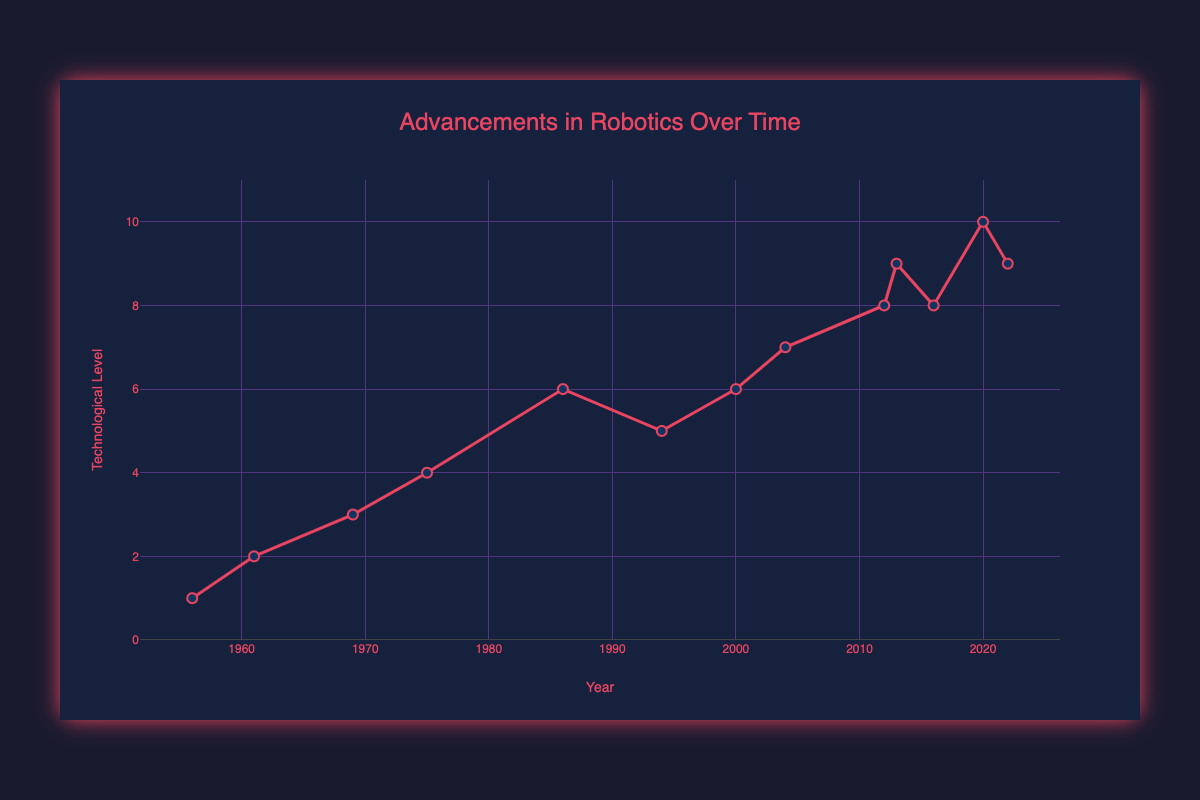Which year marked the first significant milestone in robotics, resulting in the technological level increasing from 1 to 2? The plot shows the technological level starting at 1 in 1956 and increasing to 2 in 1961. The milestone in 1961 was the deployment of the first industrial robot, Unimate, in a General Motors factory.
Answer: 1961 Between which two consecutive years did the technological level of robotics show the most significant increase? To find the most significant increase, observe the largest vertical distance between two consecutive points in the plot. The biggest jump in technological level is from 1975 (level 4) to 1986 (level 6), an increase of 2 levels.
Answer: 1975 and 1986 By how many levels did the technological level increase from 1961 to 1969? From 1961 (level 2) to 1969 (level 3), the technological level increased by subtracting 2 from 3.
Answer: 1 Which milestone was achieved in 2004, and what was the technological level at that time? The milestone in 2004 was the DARPA Grand Challenge, promoting autonomous vehicles, with the technological level at 7 as indicated by the plot.
Answer: DARPA Grand Challenge, 7 Did the technological level increase or decrease after 1986? The plot shows that the technological level after 1986 (level 6) rose in the subsequent years. Specifically, it increased to 10 by 2020, which is an increase.
Answer: Increase 